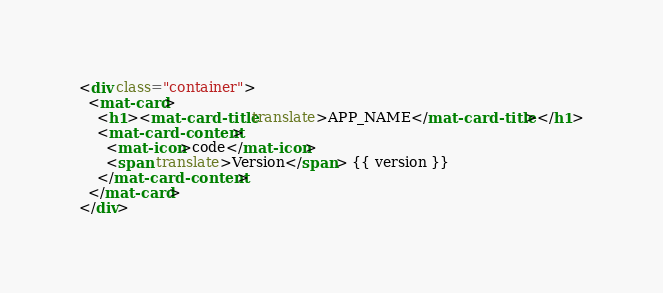<code> <loc_0><loc_0><loc_500><loc_500><_HTML_><div class="container">
  <mat-card>
    <h1><mat-card-title translate>APP_NAME</mat-card-title></h1>
    <mat-card-content>
      <mat-icon>code</mat-icon>
      <span translate>Version</span> {{ version }}
    </mat-card-content>
  </mat-card>
</div>
</code> 